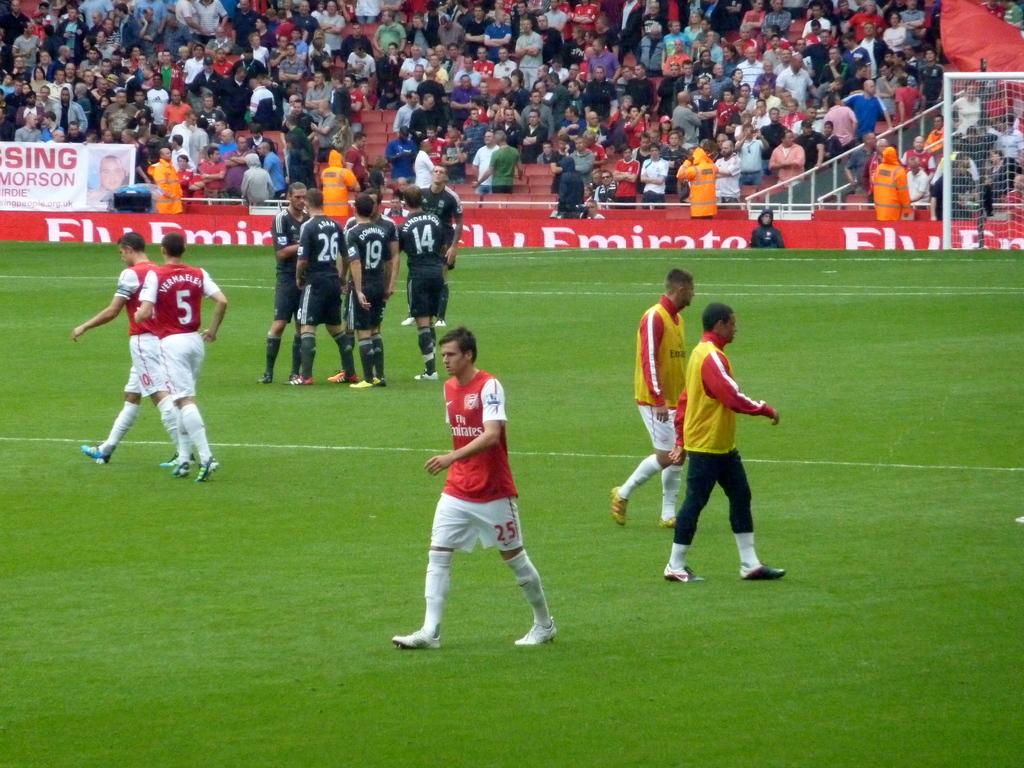What is the numbers on the back of the black shirts?
Offer a very short reply. 26, 19, 14. 